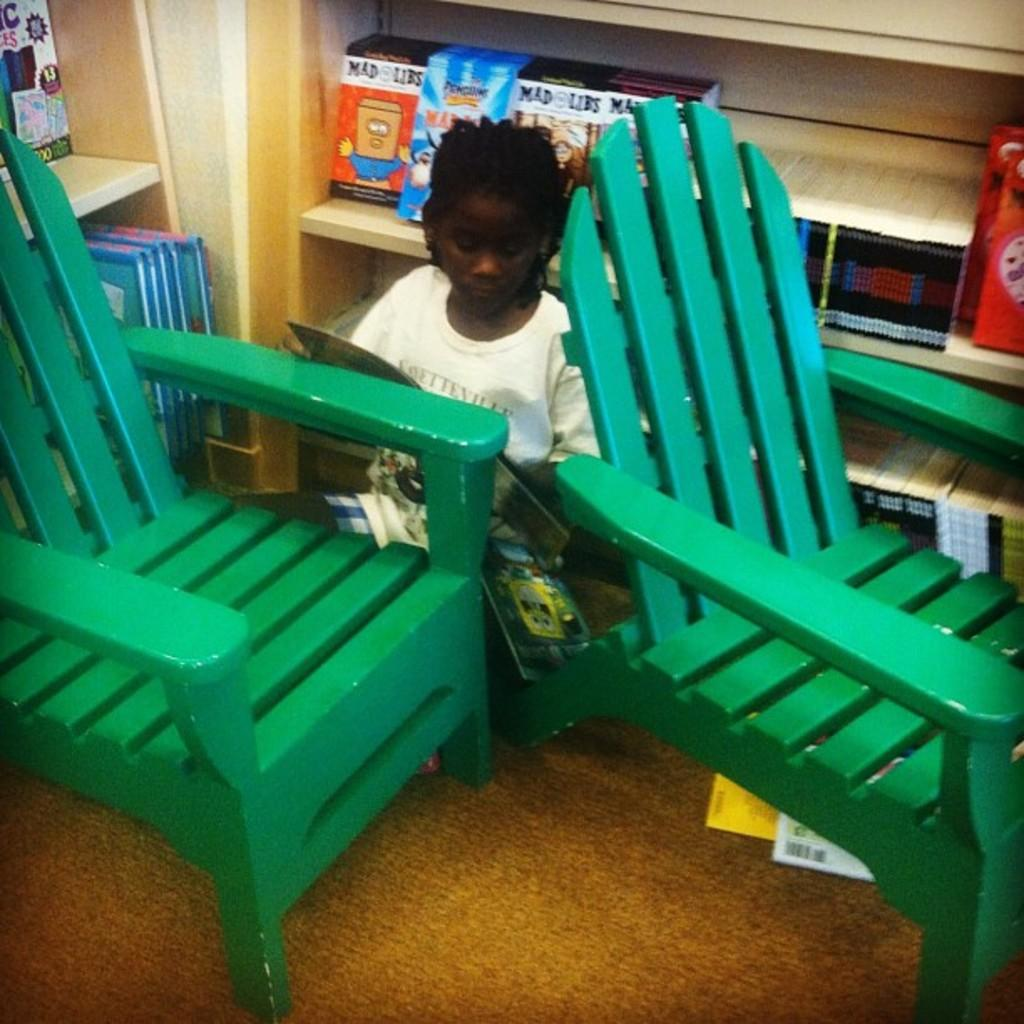Who is the main subject in the image? There is a girl in the image. What is the girl's position in relation to the chairs? The girl is sitting between two wooden chairs. What can be seen on the shelves behind the girl? There are shelves with books behind the girl. What type of corn is growing on the shelves behind the girl? There is no corn present in the image; the shelves contain books. 